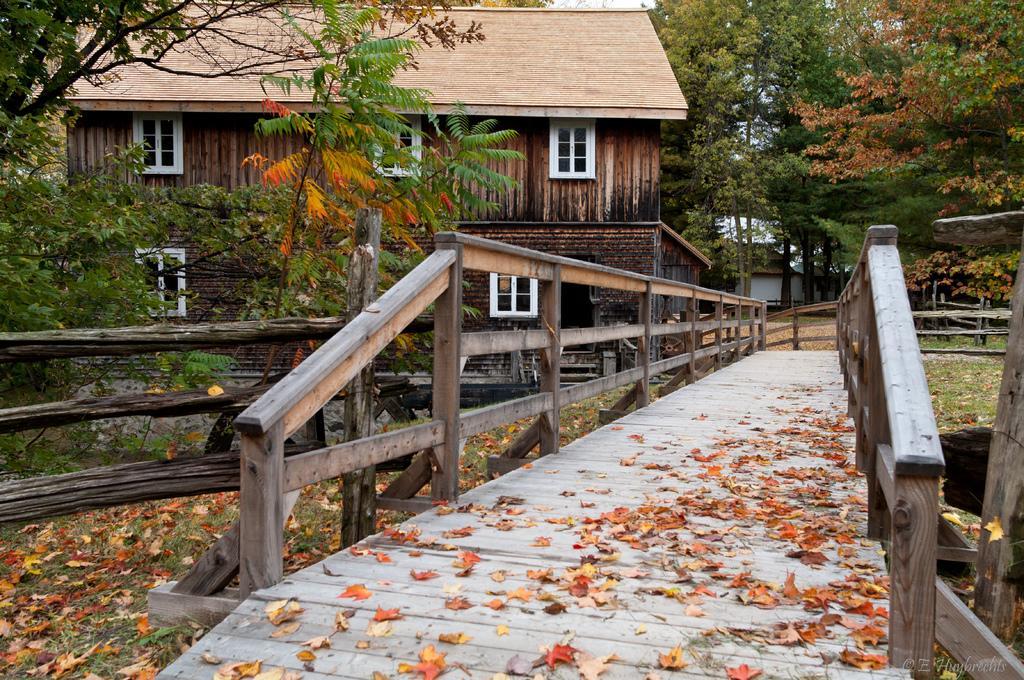Please provide a concise description of this image. In this picture I can see there is a wooden bridge and there are few dry leaves on the bridge, there is a building in the backdrop, it has few windows. There are plants, trees and the sky is clear. 